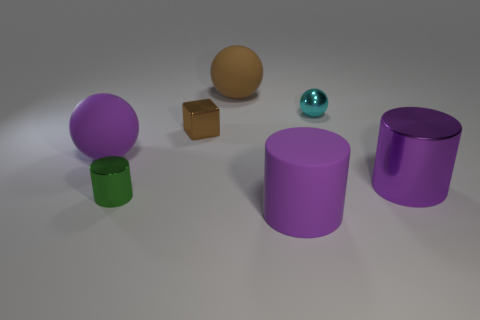There is another cylinder that is the same color as the big rubber cylinder; what is it made of?
Your response must be concise. Metal. How many large cylinders are behind the metallic cylinder left of the matte object that is in front of the big purple metal cylinder?
Ensure brevity in your answer.  1. Is there a small blue block made of the same material as the green cylinder?
Offer a very short reply. No. Is the number of purple metallic cylinders less than the number of gray rubber things?
Your answer should be very brief. No. Is the color of the cylinder in front of the tiny green thing the same as the large metal cylinder?
Your answer should be compact. Yes. What material is the tiny brown block right of the cylinder that is to the left of the big purple rubber thing that is in front of the big purple metal object?
Provide a short and direct response. Metal. Are there any matte objects of the same color as the big metallic thing?
Your response must be concise. Yes. Is the number of tiny brown metal things behind the big brown rubber thing less than the number of cylinders?
Provide a short and direct response. Yes. There is a purple rubber thing left of the brown rubber ball; is its size the same as the block?
Make the answer very short. No. How many big objects are both to the right of the tiny green thing and left of the cyan sphere?
Give a very brief answer. 2. 